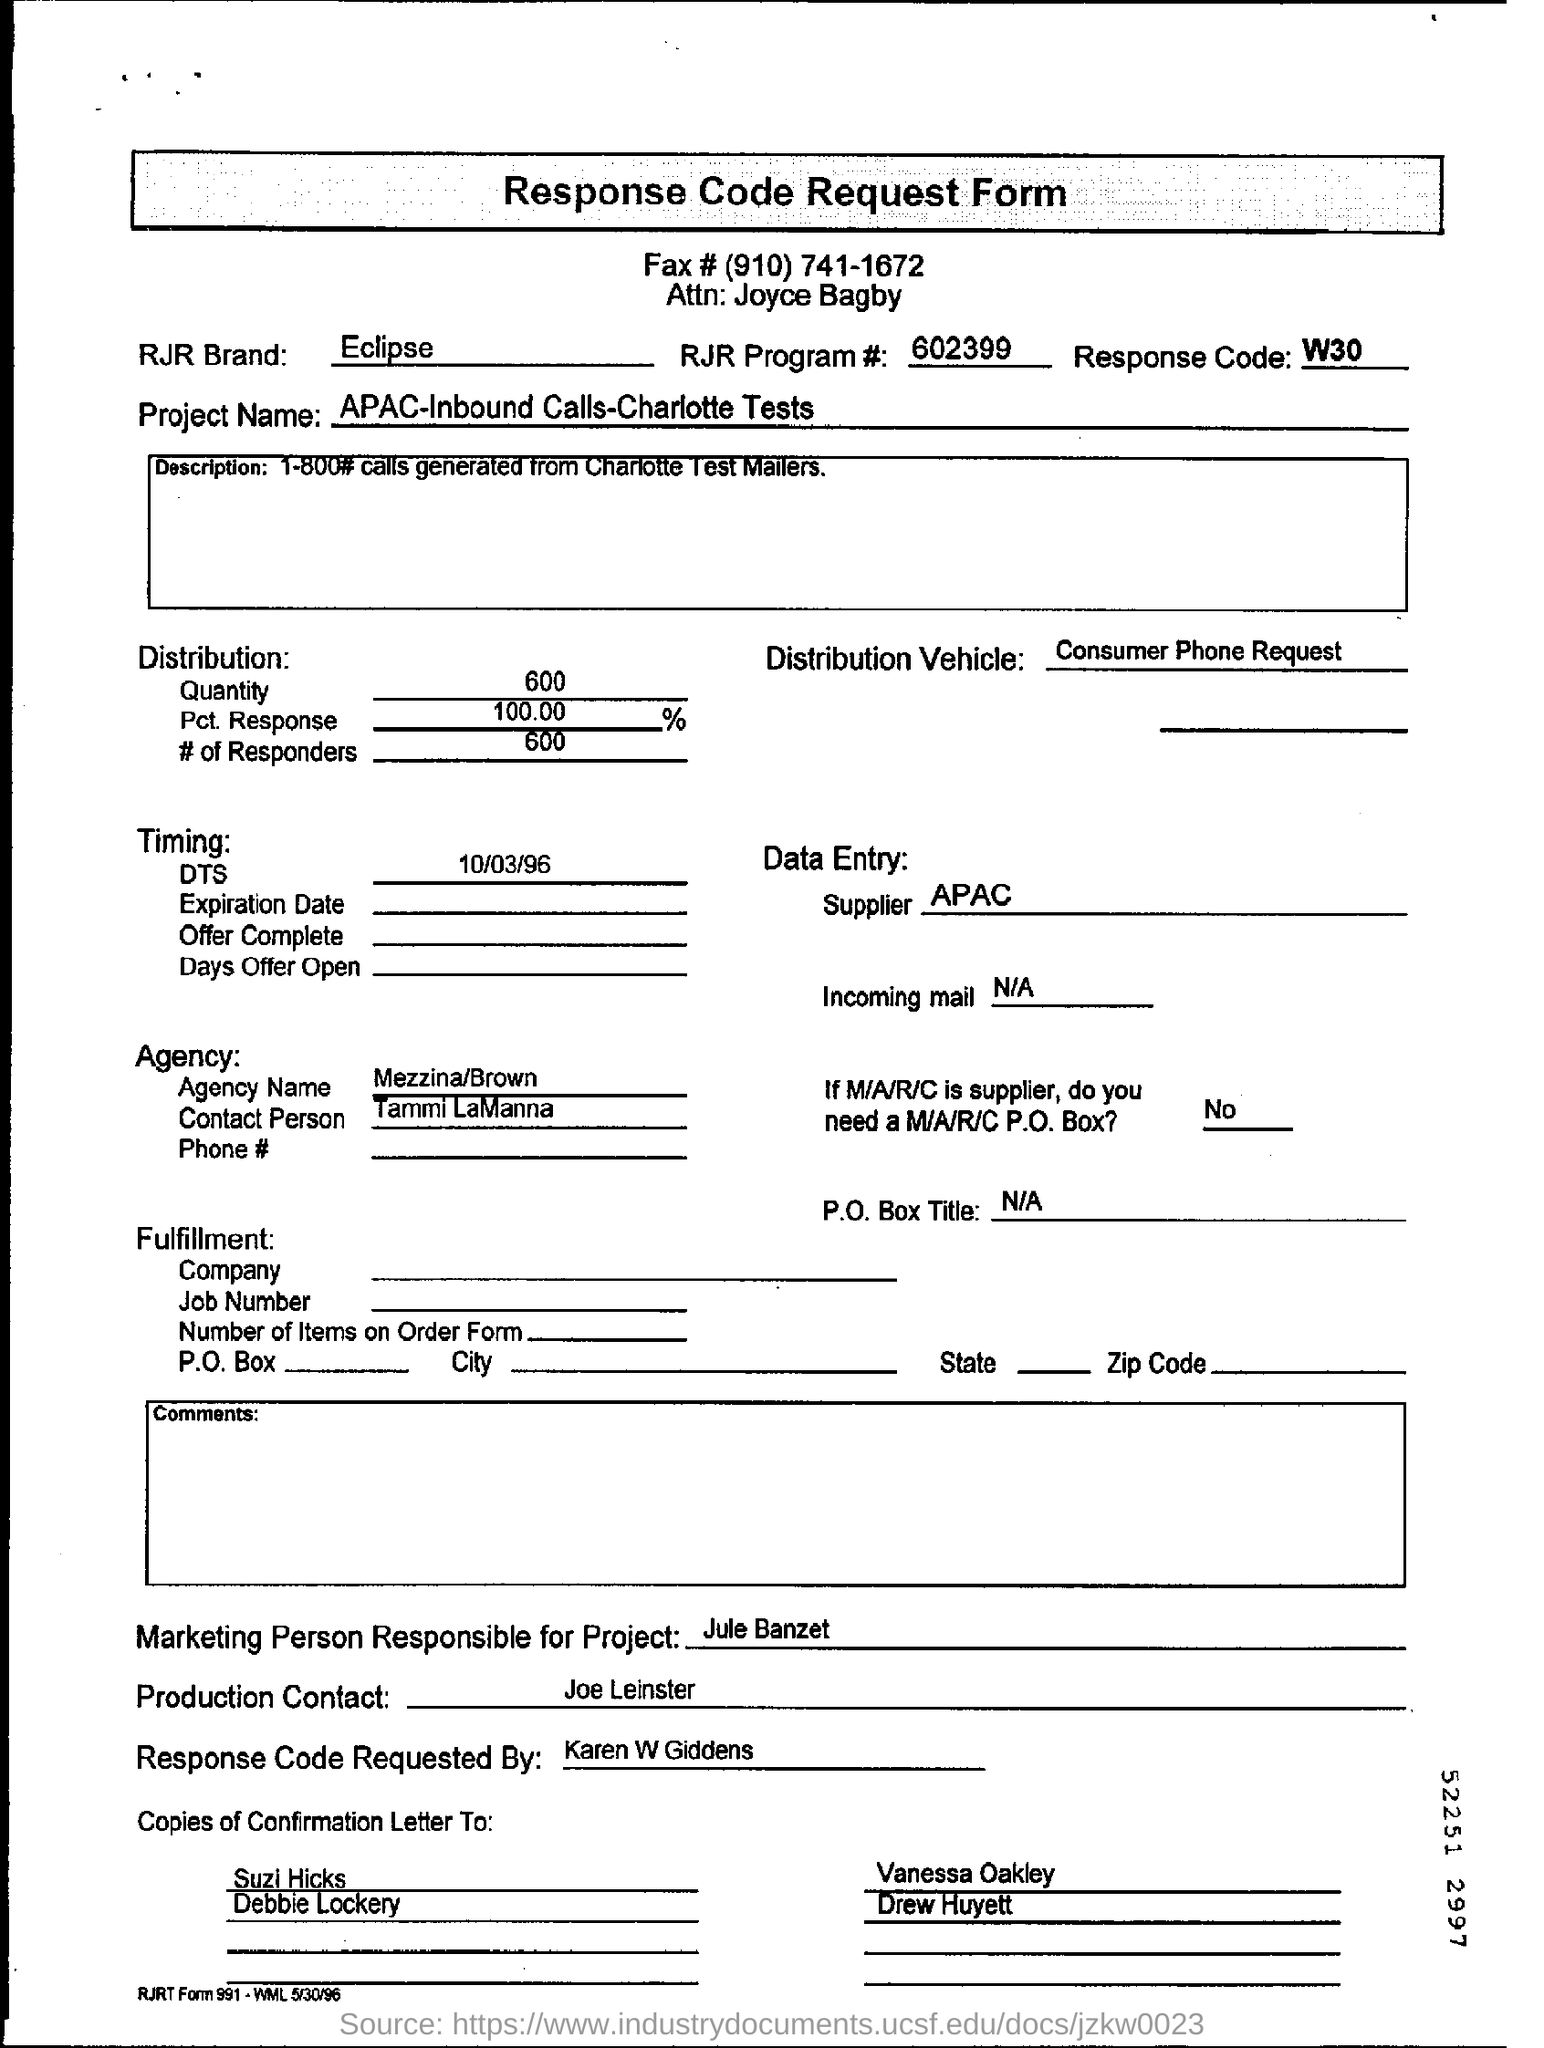Identify some key points in this picture. The marketing person responsible for the project is Jule Banzet. The Data Entry supplier is APAC. Karen W Giddens requested the Response Code. 